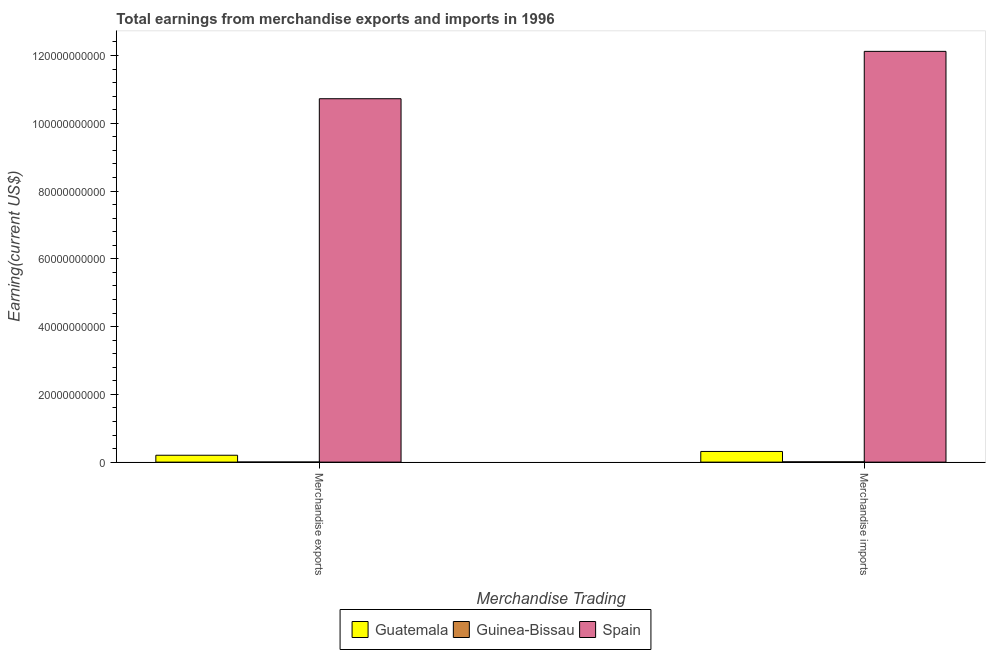How many different coloured bars are there?
Your answer should be very brief. 3. How many groups of bars are there?
Offer a terse response. 2. Are the number of bars on each tick of the X-axis equal?
Provide a short and direct response. Yes. How many bars are there on the 2nd tick from the left?
Ensure brevity in your answer.  3. How many bars are there on the 1st tick from the right?
Offer a very short reply. 3. What is the earnings from merchandise exports in Guatemala?
Give a very brief answer. 2.03e+09. Across all countries, what is the maximum earnings from merchandise exports?
Provide a short and direct response. 1.07e+11. Across all countries, what is the minimum earnings from merchandise exports?
Keep it short and to the point. 2.80e+07. In which country was the earnings from merchandise exports maximum?
Provide a short and direct response. Spain. In which country was the earnings from merchandise exports minimum?
Your answer should be compact. Guinea-Bissau. What is the total earnings from merchandise exports in the graph?
Provide a short and direct response. 1.09e+11. What is the difference between the earnings from merchandise exports in Spain and that in Guinea-Bissau?
Ensure brevity in your answer.  1.07e+11. What is the difference between the earnings from merchandise imports in Guinea-Bissau and the earnings from merchandise exports in Spain?
Provide a succinct answer. -1.07e+11. What is the average earnings from merchandise imports per country?
Provide a succinct answer. 4.15e+1. What is the difference between the earnings from merchandise imports and earnings from merchandise exports in Guinea-Bissau?
Keep it short and to the point. 5.90e+07. In how many countries, is the earnings from merchandise imports greater than 64000000000 US$?
Offer a very short reply. 1. What is the ratio of the earnings from merchandise exports in Spain to that in Guatemala?
Offer a very short reply. 52.8. Is the earnings from merchandise imports in Spain less than that in Guinea-Bissau?
Keep it short and to the point. No. What does the 2nd bar from the left in Merchandise imports represents?
Provide a short and direct response. Guinea-Bissau. What does the 1st bar from the right in Merchandise imports represents?
Offer a terse response. Spain. Does the graph contain grids?
Your response must be concise. No. What is the title of the graph?
Your response must be concise. Total earnings from merchandise exports and imports in 1996. Does "OECD members" appear as one of the legend labels in the graph?
Offer a terse response. No. What is the label or title of the X-axis?
Offer a very short reply. Merchandise Trading. What is the label or title of the Y-axis?
Keep it short and to the point. Earning(current US$). What is the Earning(current US$) of Guatemala in Merchandise exports?
Provide a short and direct response. 2.03e+09. What is the Earning(current US$) of Guinea-Bissau in Merchandise exports?
Ensure brevity in your answer.  2.80e+07. What is the Earning(current US$) in Spain in Merchandise exports?
Offer a terse response. 1.07e+11. What is the Earning(current US$) of Guatemala in Merchandise imports?
Keep it short and to the point. 3.15e+09. What is the Earning(current US$) of Guinea-Bissau in Merchandise imports?
Your answer should be compact. 8.70e+07. What is the Earning(current US$) in Spain in Merchandise imports?
Your answer should be compact. 1.21e+11. Across all Merchandise Trading, what is the maximum Earning(current US$) of Guatemala?
Keep it short and to the point. 3.15e+09. Across all Merchandise Trading, what is the maximum Earning(current US$) of Guinea-Bissau?
Provide a short and direct response. 8.70e+07. Across all Merchandise Trading, what is the maximum Earning(current US$) in Spain?
Give a very brief answer. 1.21e+11. Across all Merchandise Trading, what is the minimum Earning(current US$) in Guatemala?
Give a very brief answer. 2.03e+09. Across all Merchandise Trading, what is the minimum Earning(current US$) of Guinea-Bissau?
Offer a very short reply. 2.80e+07. Across all Merchandise Trading, what is the minimum Earning(current US$) of Spain?
Make the answer very short. 1.07e+11. What is the total Earning(current US$) in Guatemala in the graph?
Give a very brief answer. 5.18e+09. What is the total Earning(current US$) of Guinea-Bissau in the graph?
Provide a short and direct response. 1.15e+08. What is the total Earning(current US$) of Spain in the graph?
Your response must be concise. 2.28e+11. What is the difference between the Earning(current US$) in Guatemala in Merchandise exports and that in Merchandise imports?
Your response must be concise. -1.12e+09. What is the difference between the Earning(current US$) of Guinea-Bissau in Merchandise exports and that in Merchandise imports?
Provide a short and direct response. -5.90e+07. What is the difference between the Earning(current US$) of Spain in Merchandise exports and that in Merchandise imports?
Make the answer very short. -1.40e+1. What is the difference between the Earning(current US$) in Guatemala in Merchandise exports and the Earning(current US$) in Guinea-Bissau in Merchandise imports?
Ensure brevity in your answer.  1.94e+09. What is the difference between the Earning(current US$) in Guatemala in Merchandise exports and the Earning(current US$) in Spain in Merchandise imports?
Offer a terse response. -1.19e+11. What is the difference between the Earning(current US$) of Guinea-Bissau in Merchandise exports and the Earning(current US$) of Spain in Merchandise imports?
Offer a very short reply. -1.21e+11. What is the average Earning(current US$) of Guatemala per Merchandise Trading?
Make the answer very short. 2.59e+09. What is the average Earning(current US$) in Guinea-Bissau per Merchandise Trading?
Your answer should be compact. 5.75e+07. What is the average Earning(current US$) of Spain per Merchandise Trading?
Offer a very short reply. 1.14e+11. What is the difference between the Earning(current US$) in Guatemala and Earning(current US$) in Guinea-Bissau in Merchandise exports?
Give a very brief answer. 2.00e+09. What is the difference between the Earning(current US$) in Guatemala and Earning(current US$) in Spain in Merchandise exports?
Offer a terse response. -1.05e+11. What is the difference between the Earning(current US$) in Guinea-Bissau and Earning(current US$) in Spain in Merchandise exports?
Make the answer very short. -1.07e+11. What is the difference between the Earning(current US$) of Guatemala and Earning(current US$) of Guinea-Bissau in Merchandise imports?
Ensure brevity in your answer.  3.06e+09. What is the difference between the Earning(current US$) of Guatemala and Earning(current US$) of Spain in Merchandise imports?
Provide a short and direct response. -1.18e+11. What is the difference between the Earning(current US$) of Guinea-Bissau and Earning(current US$) of Spain in Merchandise imports?
Give a very brief answer. -1.21e+11. What is the ratio of the Earning(current US$) of Guatemala in Merchandise exports to that in Merchandise imports?
Offer a terse response. 0.65. What is the ratio of the Earning(current US$) in Guinea-Bissau in Merchandise exports to that in Merchandise imports?
Offer a terse response. 0.32. What is the ratio of the Earning(current US$) of Spain in Merchandise exports to that in Merchandise imports?
Provide a succinct answer. 0.88. What is the difference between the highest and the second highest Earning(current US$) in Guatemala?
Offer a terse response. 1.12e+09. What is the difference between the highest and the second highest Earning(current US$) in Guinea-Bissau?
Ensure brevity in your answer.  5.90e+07. What is the difference between the highest and the second highest Earning(current US$) of Spain?
Your answer should be very brief. 1.40e+1. What is the difference between the highest and the lowest Earning(current US$) of Guatemala?
Give a very brief answer. 1.12e+09. What is the difference between the highest and the lowest Earning(current US$) of Guinea-Bissau?
Ensure brevity in your answer.  5.90e+07. What is the difference between the highest and the lowest Earning(current US$) in Spain?
Give a very brief answer. 1.40e+1. 